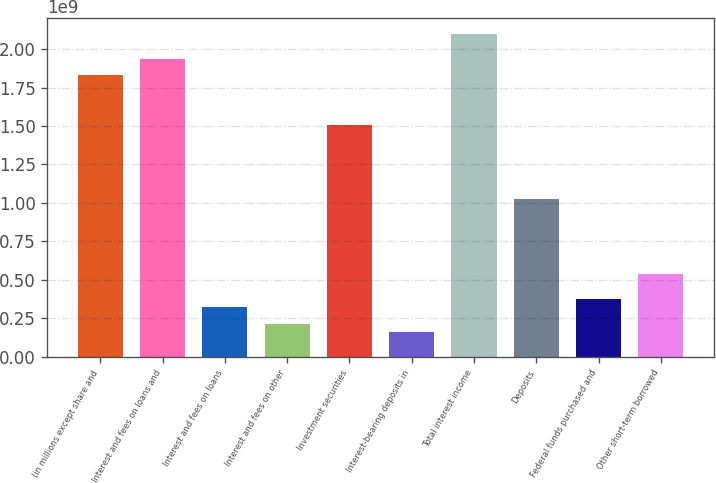Convert chart. <chart><loc_0><loc_0><loc_500><loc_500><bar_chart><fcel>(in millions except share and<fcel>Interest and fees on loans and<fcel>Interest and fees on loans<fcel>Interest and fees on other<fcel>Investment securities<fcel>Interest-bearing deposits in<fcel>Total interest income<fcel>Deposits<fcel>Federal funds purchased and<fcel>Other short-term borrowed<nl><fcel>1.82995e+09<fcel>1.9376e+09<fcel>3.22933e+08<fcel>2.15288e+08<fcel>1.50702e+09<fcel>1.61466e+08<fcel>2.09906e+09<fcel>1.02262e+09<fcel>3.76755e+08<fcel>5.38221e+08<nl></chart> 